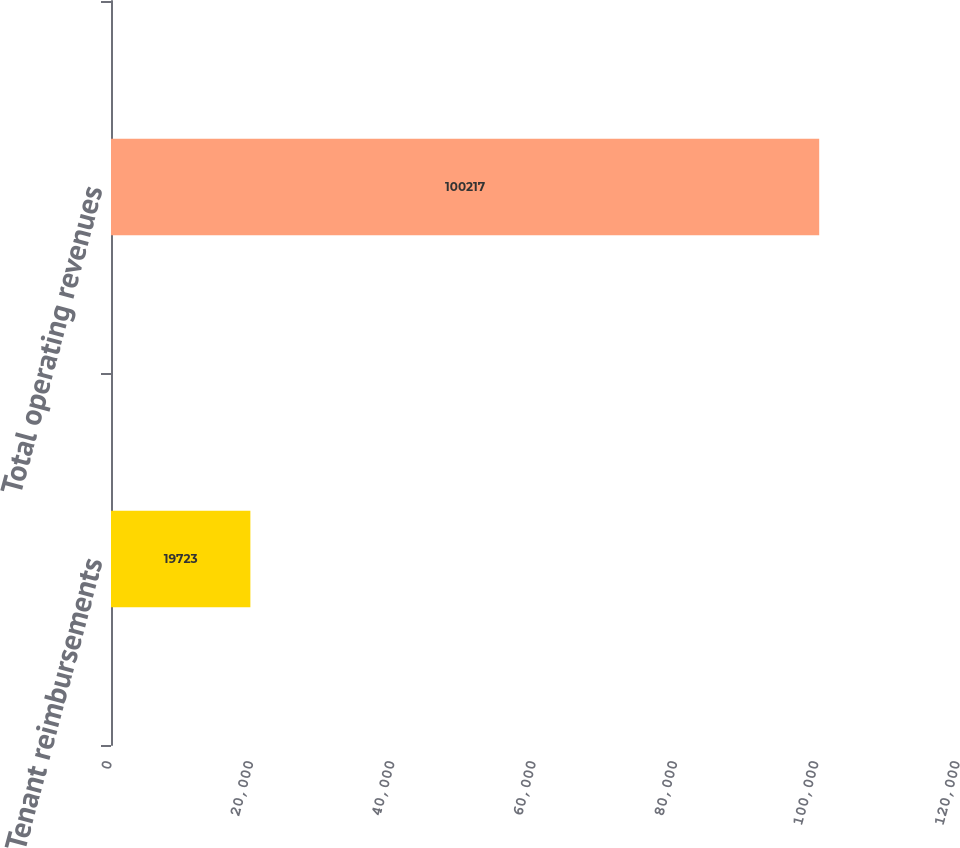Convert chart. <chart><loc_0><loc_0><loc_500><loc_500><bar_chart><fcel>Tenant reimbursements<fcel>Total operating revenues<nl><fcel>19723<fcel>100217<nl></chart> 